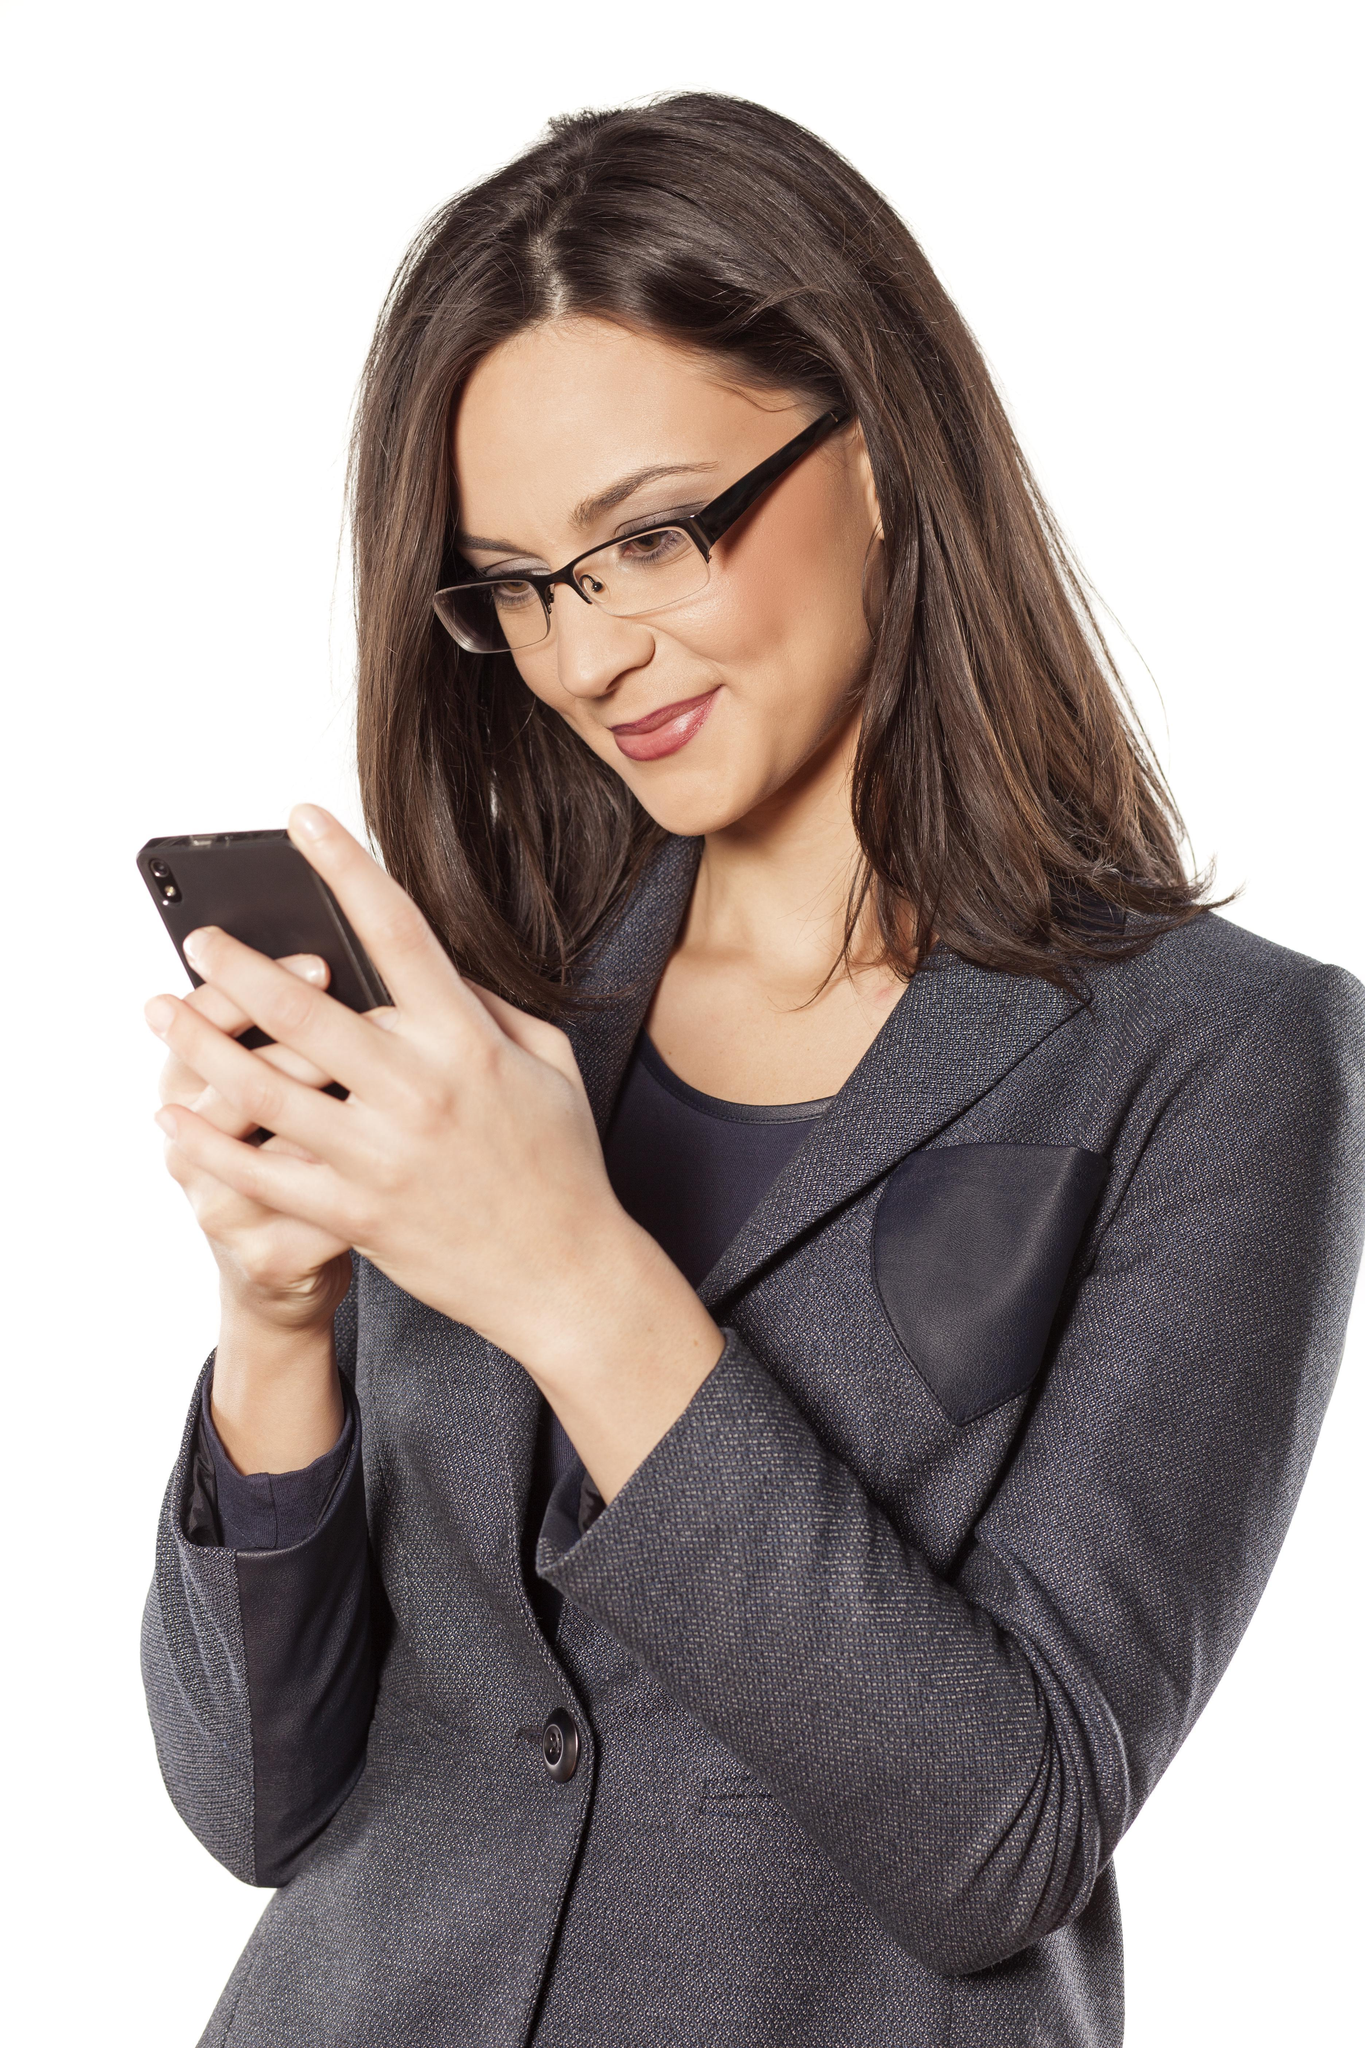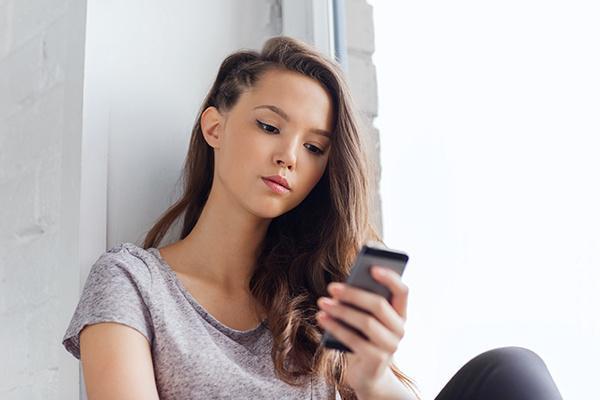The first image is the image on the left, the second image is the image on the right. Examine the images to the left and right. Is the description "Each of the images shows a female holding and looking at a cell phone." accurate? Answer yes or no. Yes. The first image is the image on the left, the second image is the image on the right. Evaluate the accuracy of this statement regarding the images: "There are two brown haired women holding their phones.". Is it true? Answer yes or no. Yes. 